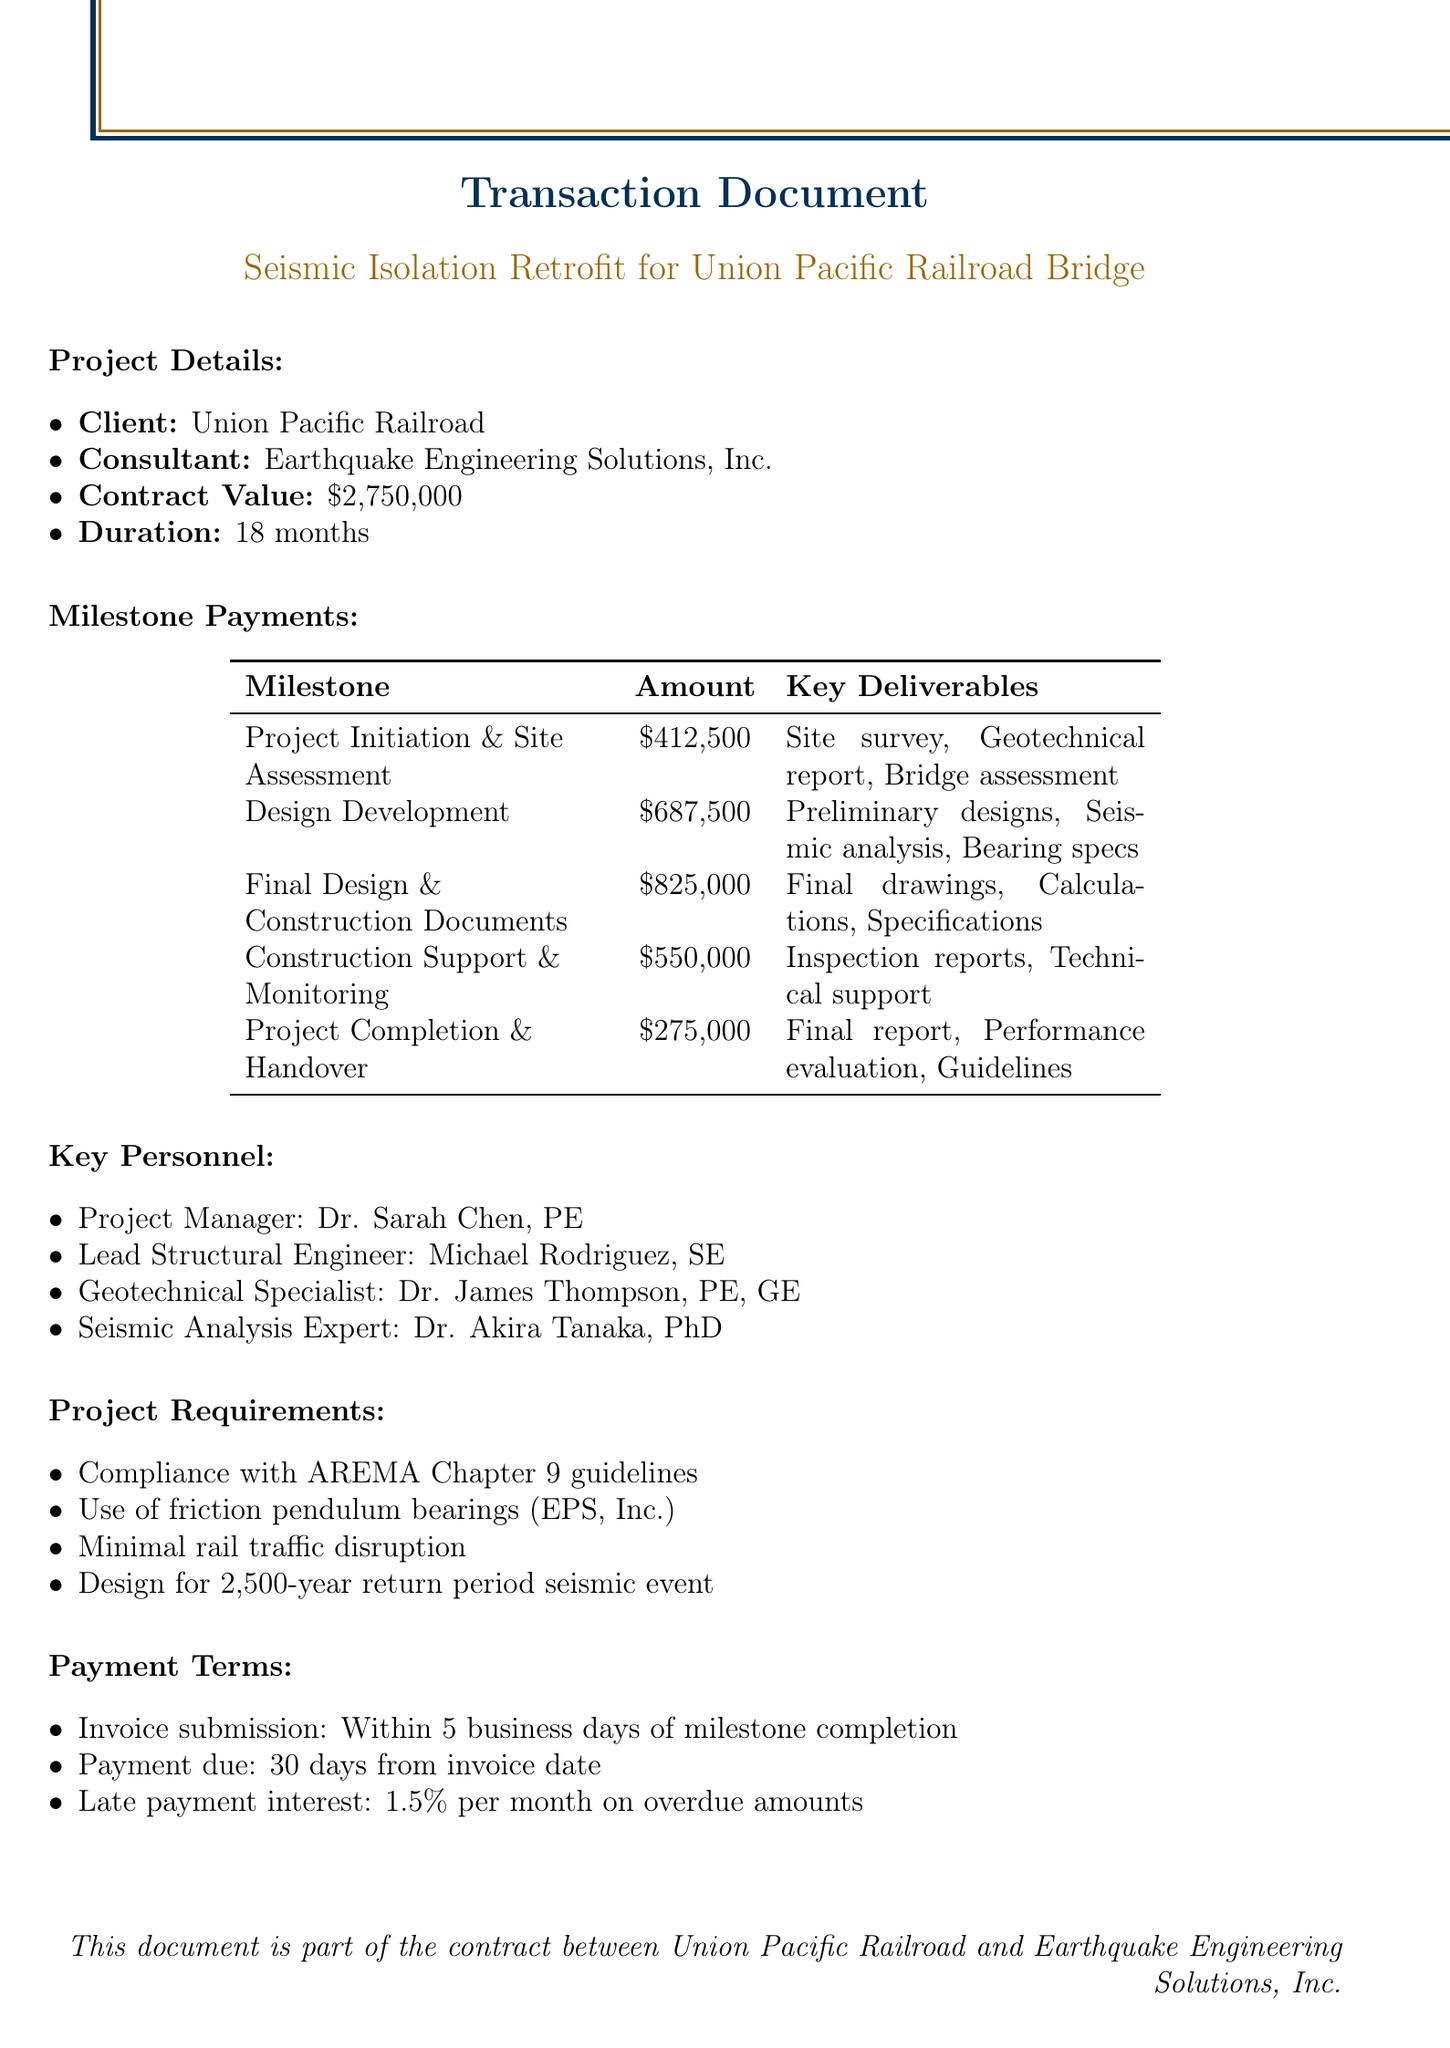What is the contract value? The contract value is explicitly stated in the document as the total amount for the consulting project.
Answer: $2,750,000 Who is the client for the project? The document clearly identifies the client involved in the project under the project details section.
Answer: Union Pacific Railroad What percentage of the contract is allocated for the Design Development milestone? The document specifies the payment percentage corresponding to each milestone.
Answer: 25% What is the total amount for the final milestone payment? The document lists the amount of each milestone, including the final payment for project completion.
Answer: $275,000 Who is the project manager? The document mentions key personnel and their respective roles, including the project manager.
Answer: Dr. Sarah Chen, PE What is the duration of the project? The project duration is provided clearly among the project details.
Answer: 18 months What is the payment due period after invoice submission? The document states the specific timeframe allocated for payment after invoices are submitted.
Answer: 30 days Which guidelines must be complied with during the project? The document indicates project-specific requirements, including applicable guidelines necessary for the project.
Answer: AREMA Chapter 9 What is the interest rate on overdue payments? The document specifies the late payment interest applicable to overdue amounts as part of the payment terms.
Answer: 1.5% per month 